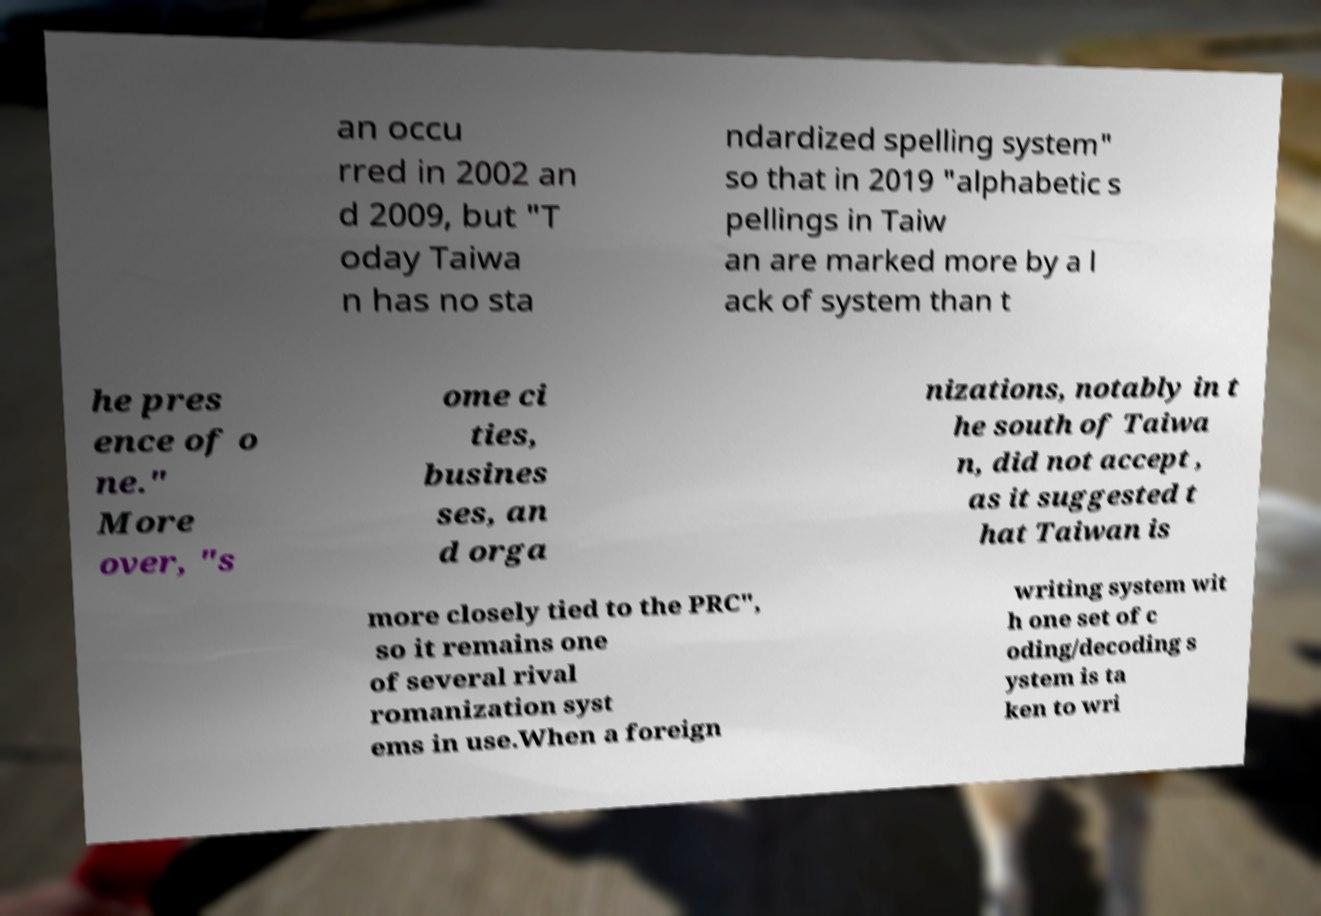For documentation purposes, I need the text within this image transcribed. Could you provide that? an occu rred in 2002 an d 2009, but "T oday Taiwa n has no sta ndardized spelling system" so that in 2019 "alphabetic s pellings in Taiw an are marked more by a l ack of system than t he pres ence of o ne." More over, "s ome ci ties, busines ses, an d orga nizations, notably in t he south of Taiwa n, did not accept , as it suggested t hat Taiwan is more closely tied to the PRC", so it remains one of several rival romanization syst ems in use.When a foreign writing system wit h one set of c oding/decoding s ystem is ta ken to wri 